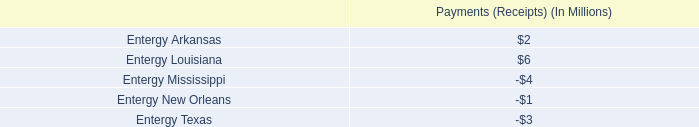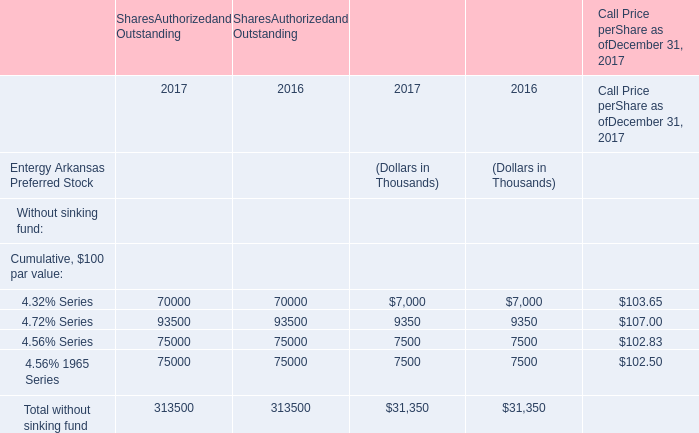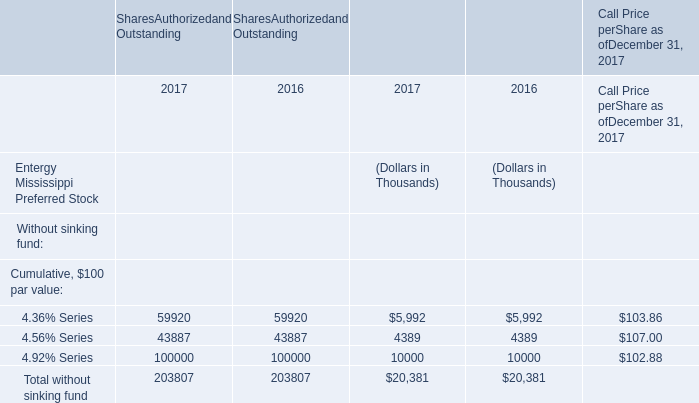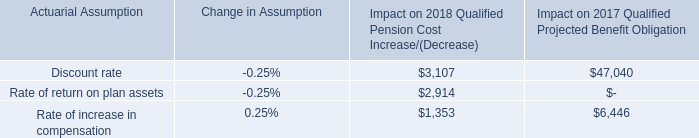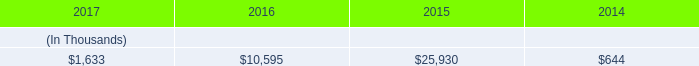What is the sum of the 4.72% Series in the years where 4.32% Series is positive for SharesAuthorizedand Outstanding? (in thousand) 
Computations: (93500 + 93500)
Answer: 187000.0. 